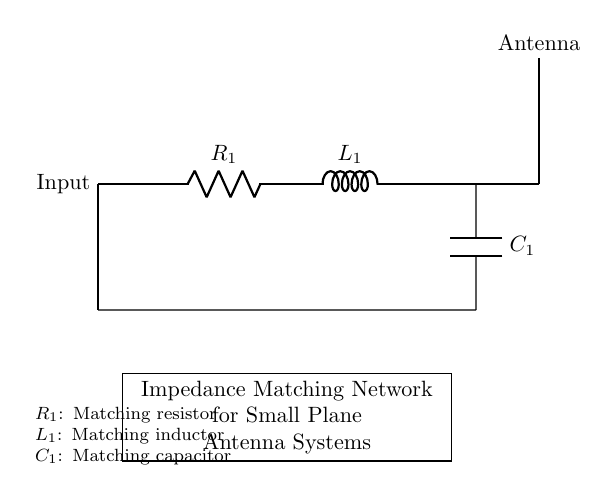What does R1 represent in this circuit? R1 is labeled as the matching resistor in the circuit diagram. It is used in impedance matching to maximize power transfer to the antenna.
Answer: matching resistor What component is connected in series with R1? The circuit shows that L1, the matching inductor, is directly connected to R1 in series. This indicates that the inductor is part of the impedance matching network.
Answer: L1 How many components are there in total in this antenna matching network circuit? The circuit diagram includes three components: a resistor (R1), an inductor (L1), and a capacitor (C1), making a total of three components.
Answer: three What is the function of C1 in this circuit? C1 is labeled as the matching capacitor, and its function is to help with the impedance matching process by adjusting the reactive component of the impedance at the antenna.
Answer: matching capacitor What type of circuit is shown in this diagram? This diagram illustrates a passive impedance matching network that uses resistive, inductive, and capacitive components to match the impedance for optimal antenna performance.
Answer: passive impedance matching network Why is impedance matching necessary for antenna systems? Impedance matching increases the power transfer efficiency between the antenna and the transmitter/receiver by reducing reflections, which can lead to signal loss.
Answer: increase power transfer efficiency What does the connection to the antenna indicate in the circuit? The connection to the antenna signifies that the impedance matching network is designed to optimize the performance of the antenna by ensuring it operates effectively at the desired frequency.
Answer: optimize antenna performance 